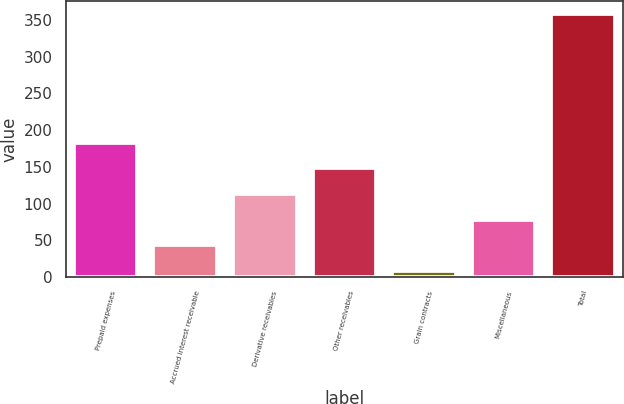Convert chart. <chart><loc_0><loc_0><loc_500><loc_500><bar_chart><fcel>Prepaid expenses<fcel>Accrued interest receivable<fcel>Derivative receivables<fcel>Other receivables<fcel>Grain contracts<fcel>Miscellaneous<fcel>Total<nl><fcel>183.2<fcel>43.28<fcel>113.24<fcel>148.22<fcel>8.3<fcel>78.26<fcel>358.1<nl></chart> 